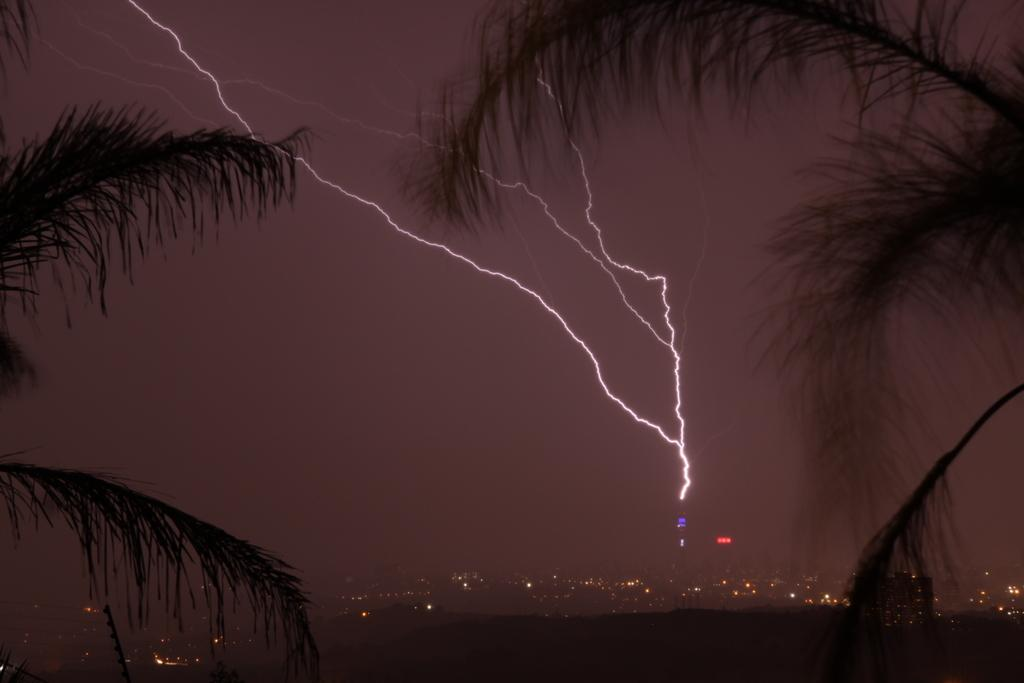What type of vegetation can be seen on both sides of the image? There are trees on both sides of the image. What is the lighting condition in the foreground of the image? There is darkness in the foreground of the image. What can be seen in the image that provides illumination? There are lights visible in the image. What is the appearance of the sky in the image? There is a sparkle in the sky. How long does it take for the hill to pass by in the image? There is no hill present in the image, so it cannot be determined how long it would take for it to pass by. What color is the minute in the image? There is no reference to a minute or any specific color in the image. 